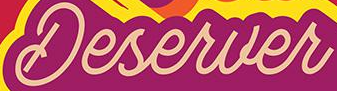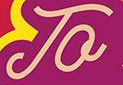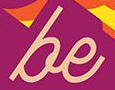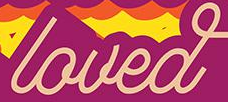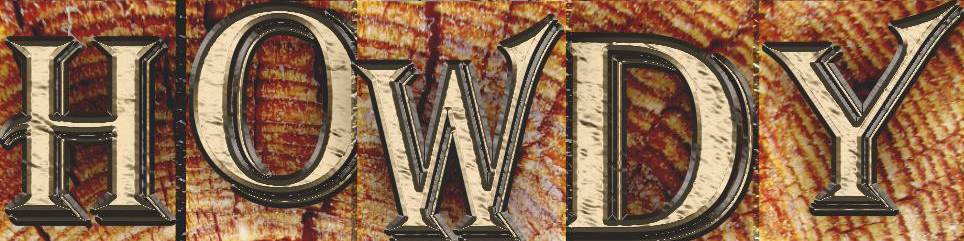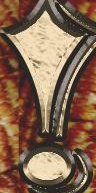Identify the words shown in these images in order, separated by a semicolon. Deserver; To; be; loved; HOWDY; ! 